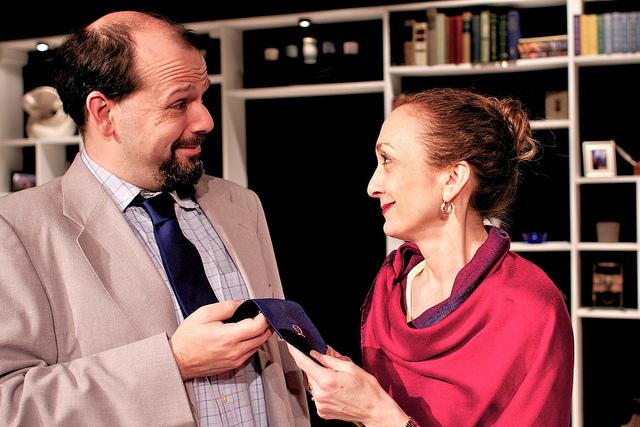Is the man wearing a tie?
Write a very short answer. Yes. What activity are the people engaged in?
Concise answer only. Shopping. Does the woman have on a low neck top?
Be succinct. No. 